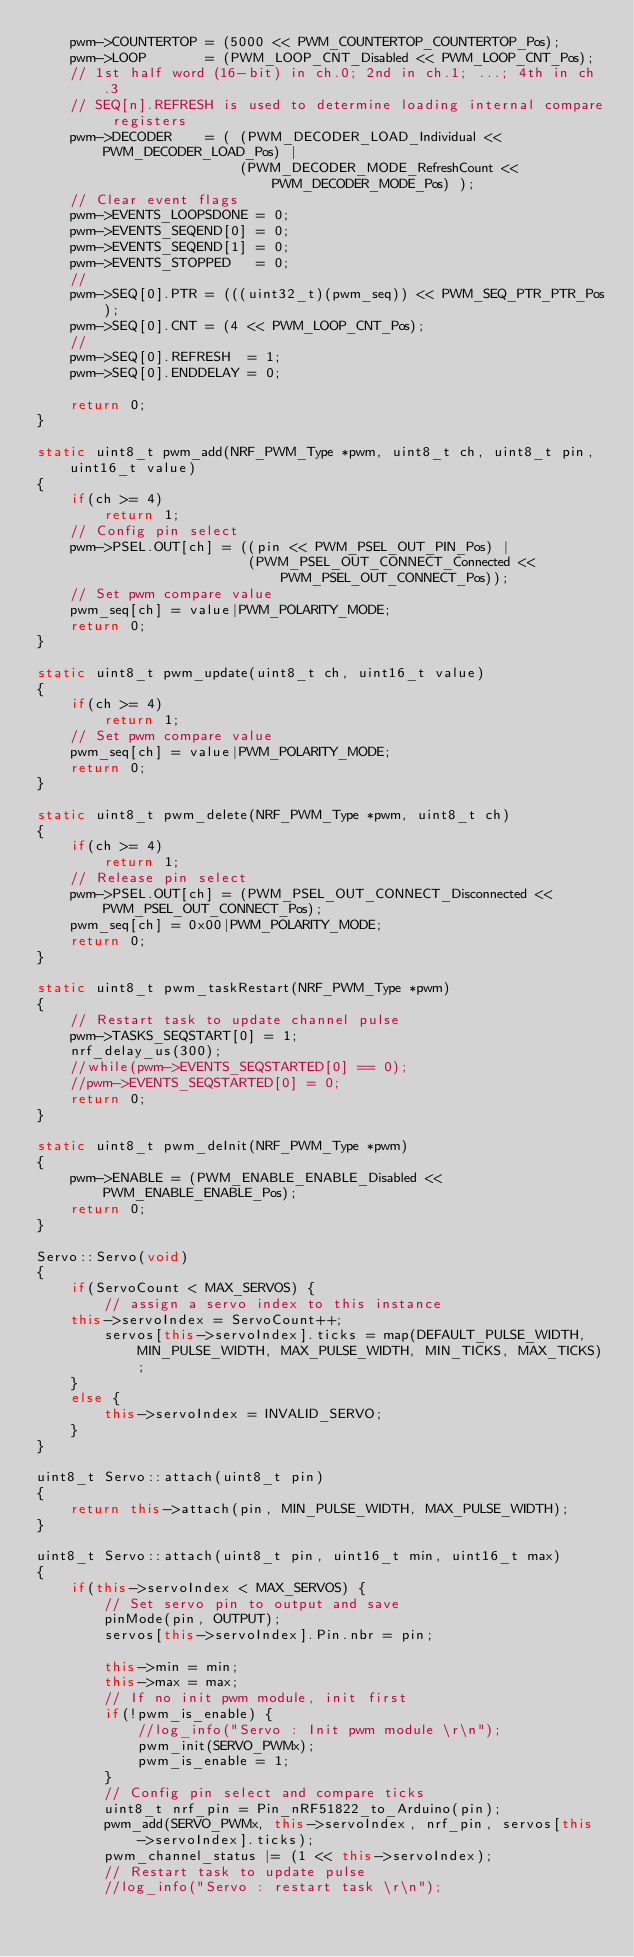<code> <loc_0><loc_0><loc_500><loc_500><_C++_>    pwm->COUNTERTOP = (5000 << PWM_COUNTERTOP_COUNTERTOP_Pos);
    pwm->LOOP       = (PWM_LOOP_CNT_Disabled << PWM_LOOP_CNT_Pos);
    // 1st half word (16-bit) in ch.0; 2nd in ch.1; ...; 4th in ch.3
    // SEQ[n].REFRESH is used to determine loading internal compare registers
    pwm->DECODER    = ( (PWM_DECODER_LOAD_Individual << PWM_DECODER_LOAD_Pos) |
                        (PWM_DECODER_MODE_RefreshCount << PWM_DECODER_MODE_Pos) );                         
    // Clear event flags
    pwm->EVENTS_LOOPSDONE = 0;
    pwm->EVENTS_SEQEND[0] = 0;
    pwm->EVENTS_SEQEND[1] = 0;
    pwm->EVENTS_STOPPED   = 0;
    //   
    pwm->SEQ[0].PTR = (((uint32_t)(pwm_seq)) << PWM_SEQ_PTR_PTR_Pos);
    pwm->SEQ[0].CNT = (4 << PWM_LOOP_CNT_Pos);
    //
    pwm->SEQ[0].REFRESH  = 1;
    pwm->SEQ[0].ENDDELAY = 0;
    
    return 0;    
}

static uint8_t pwm_add(NRF_PWM_Type *pwm, uint8_t ch, uint8_t pin, uint16_t value)
{
    if(ch >= 4)
        return 1;
    // Config pin select
    pwm->PSEL.OUT[ch] = ((pin << PWM_PSEL_OUT_PIN_Pos) |
                         (PWM_PSEL_OUT_CONNECT_Connected << PWM_PSEL_OUT_CONNECT_Pos));
    // Set pwm compare value
    pwm_seq[ch] = value|PWM_POLARITY_MODE;
    return 0;
}

static uint8_t pwm_update(uint8_t ch, uint16_t value)
{
    if(ch >= 4)
        return 1;
    // Set pwm compare value
    pwm_seq[ch] = value|PWM_POLARITY_MODE;
    return 0;
}

static uint8_t pwm_delete(NRF_PWM_Type *pwm, uint8_t ch)
{
    if(ch >= 4)
        return 1;
    // Release pin select
    pwm->PSEL.OUT[ch] = (PWM_PSEL_OUT_CONNECT_Disconnected << PWM_PSEL_OUT_CONNECT_Pos);
    pwm_seq[ch] = 0x00|PWM_POLARITY_MODE;   
    return 0;
}

static uint8_t pwm_taskRestart(NRF_PWM_Type *pwm)
{
    // Restart task to update channel pulse
    pwm->TASKS_SEQSTART[0] = 1;
    nrf_delay_us(300);
    //while(pwm->EVENTS_SEQSTARTED[0] == 0);
    //pwm->EVENTS_SEQSTARTED[0] = 0;
    return 0;
}

static uint8_t pwm_deInit(NRF_PWM_Type *pwm)
{
    pwm->ENABLE = (PWM_ENABLE_ENABLE_Disabled << PWM_ENABLE_ENABLE_Pos);
    return 0;
}

Servo::Servo(void)
{
    if(ServoCount < MAX_SERVOS) {
        // assign a servo index to this instance
		this->servoIndex = ServoCount++;
        servos[this->servoIndex].ticks = map(DEFAULT_PULSE_WIDTH, MIN_PULSE_WIDTH, MAX_PULSE_WIDTH, MIN_TICKS, MAX_TICKS);
    }
    else {
        this->servoIndex = INVALID_SERVO;
    }
}

uint8_t Servo::attach(uint8_t pin)
{
    return this->attach(pin, MIN_PULSE_WIDTH, MAX_PULSE_WIDTH);
}

uint8_t Servo::attach(uint8_t pin, uint16_t min, uint16_t max)
{
    if(this->servoIndex < MAX_SERVOS) {
        // Set servo pin to output and save
        pinMode(pin, OUTPUT);
        servos[this->servoIndex].Pin.nbr = pin;
        
        this->min = min;
        this->max = max;
        // If no init pwm module, init first
        if(!pwm_is_enable) {
            //log_info("Servo : Init pwm module \r\n");
            pwm_init(SERVO_PWMx);
            pwm_is_enable = 1;
        }
        // Config pin select and compare ticks
        uint8_t nrf_pin = Pin_nRF51822_to_Arduino(pin);
        pwm_add(SERVO_PWMx, this->servoIndex, nrf_pin, servos[this->servoIndex].ticks);
        pwm_channel_status |= (1 << this->servoIndex);
        // Restart task to update pulse
        //log_info("Servo : restart task \r\n");</code> 